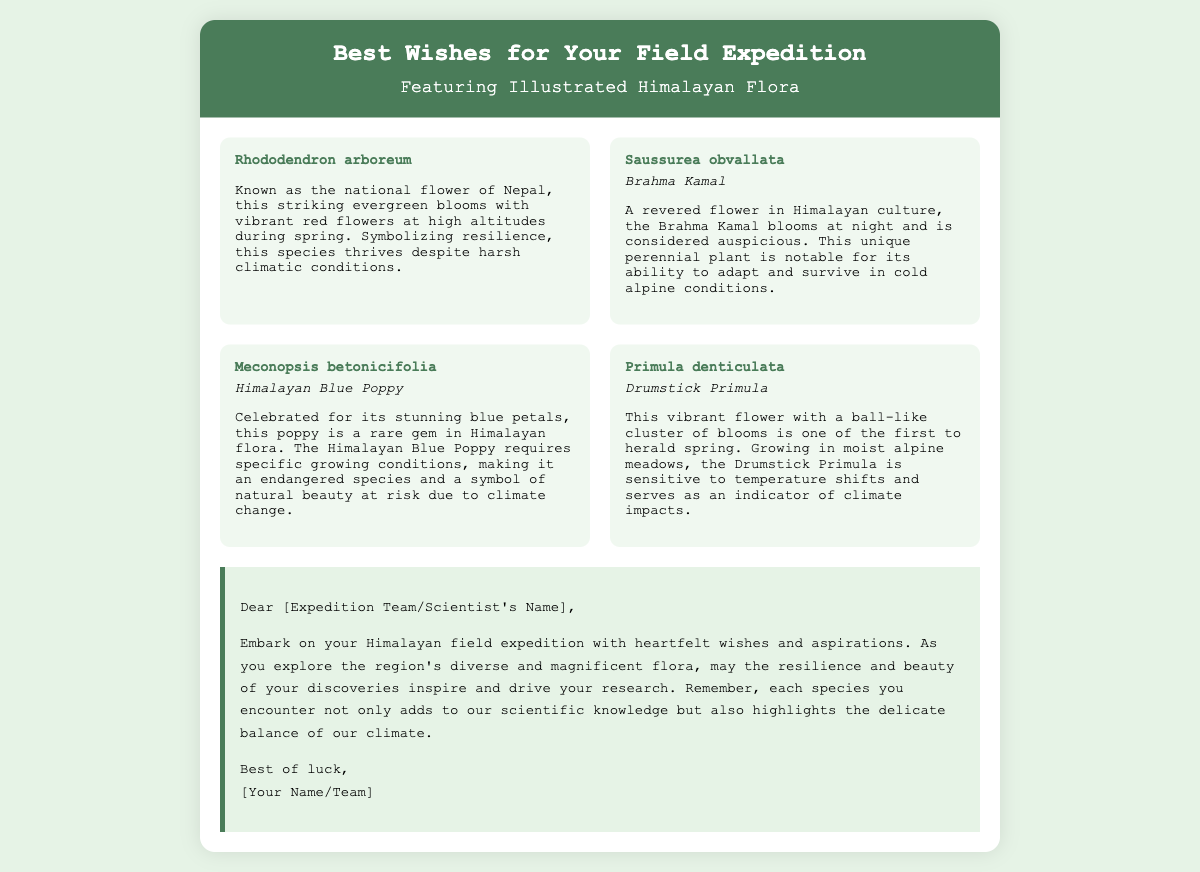what is the title of the card? The title is displayed prominently at the top of the card.
Answer: Best Wishes for Your Field Expedition who is the national flower of Nepal? The document lists a species that is recognized as the national flower of Nepal.
Answer: Rhododendron arboreum what is the common name of Saussurea obvallata? The document specifies the common name of this flower under its scientific name.
Answer: Brahma Kamal how many flora items are illustrated in the card? The card features a grid layout showcasing several flora items.
Answer: Four which flower symbolizes resilience and thrives in harsh conditions? The document mentions a specific species known for this attribute.
Answer: Rhododendron arboreum what does the Drumstick Primula indicate? The document describes the significance of this flower in relation to climate.
Answer: Climate impacts who is the intended recipient of this message? The greeting card is directed towards a specific audience for the expedition.
Answer: Expedition Team/Scientist's Name what color are the petals of the Himalayan Blue Poppy? The document describes this flower's petal color explicitly.
Answer: Blue 